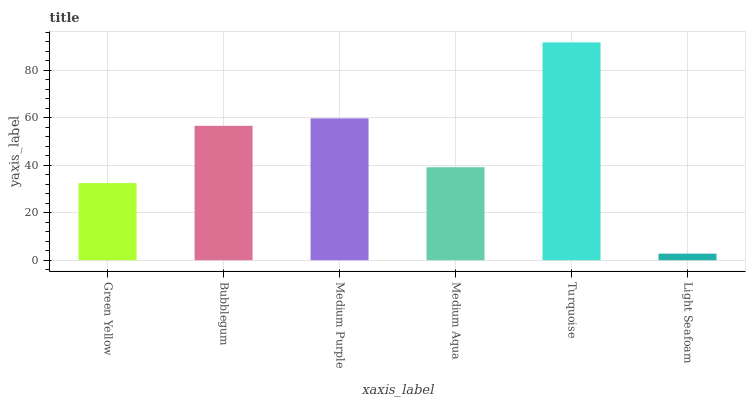Is Light Seafoam the minimum?
Answer yes or no. Yes. Is Turquoise the maximum?
Answer yes or no. Yes. Is Bubblegum the minimum?
Answer yes or no. No. Is Bubblegum the maximum?
Answer yes or no. No. Is Bubblegum greater than Green Yellow?
Answer yes or no. Yes. Is Green Yellow less than Bubblegum?
Answer yes or no. Yes. Is Green Yellow greater than Bubblegum?
Answer yes or no. No. Is Bubblegum less than Green Yellow?
Answer yes or no. No. Is Bubblegum the high median?
Answer yes or no. Yes. Is Medium Aqua the low median?
Answer yes or no. Yes. Is Medium Purple the high median?
Answer yes or no. No. Is Light Seafoam the low median?
Answer yes or no. No. 